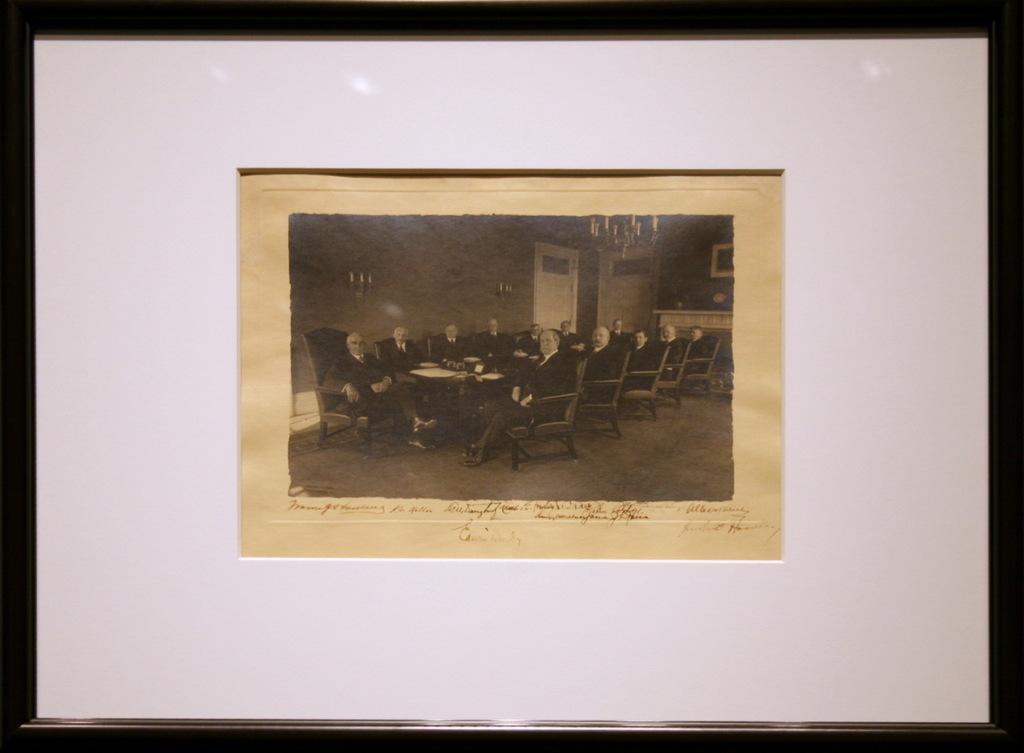In one or two sentences, can you explain what this image depicts? In this image we can see a group of people sitting on chairs. In the center of the image we can see some objects placed on the table. On the right side of the image we can see a photo frame on the wall. In the background, we can see some candles placed on stands and some doors. At the top of the image we can see a chandelier. At the bottom of the image we can see some text. 